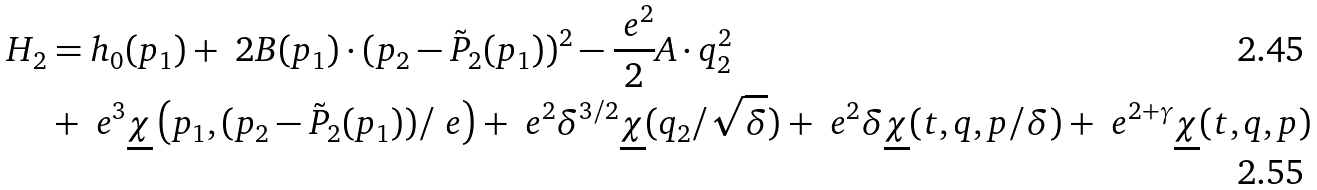Convert formula to latex. <formula><loc_0><loc_0><loc_500><loc_500>H _ { 2 } & = h _ { 0 } ( p _ { 1 } ) + \ 2 B ( p _ { 1 } ) \cdot ( p _ { 2 } - \tilde { P } _ { 2 } ( p _ { 1 } ) ) ^ { 2 } - \frac { \ e ^ { 2 } } { 2 } A \cdot q _ { 2 } ^ { 2 } \\ & + \ e ^ { 3 } \underline { \chi } \left ( p _ { 1 } , ( p _ { 2 } - \tilde { P } _ { 2 } ( p _ { 1 } ) ) / \ e \right ) + \ e ^ { 2 } \delta ^ { 3 / 2 } \underline { \chi } ( q _ { 2 } / \sqrt { \delta } ) + \ e ^ { 2 } \delta \underline { \chi } ( t , q , p / \delta ) + \ e ^ { 2 + \gamma } \underline { \chi } ( t , q , p )</formula> 